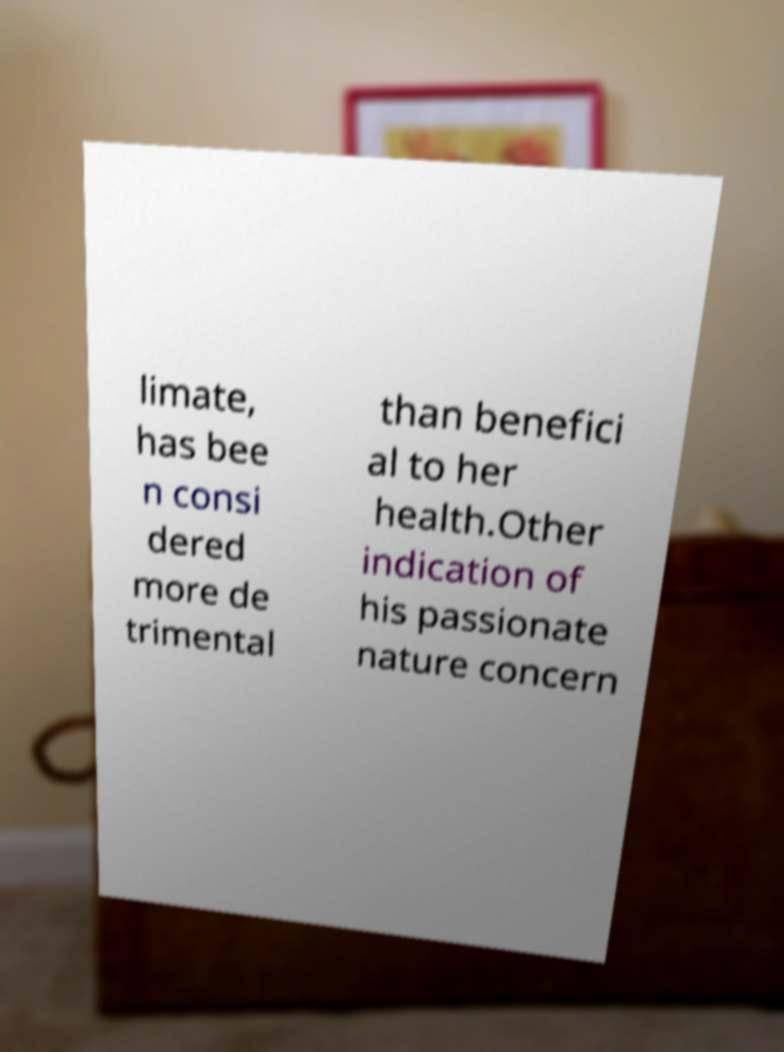Can you read and provide the text displayed in the image?This photo seems to have some interesting text. Can you extract and type it out for me? limate, has bee n consi dered more de trimental than benefici al to her health.Other indication of his passionate nature concern 